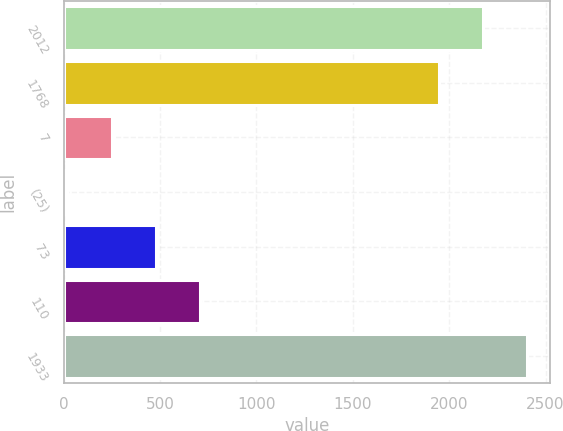<chart> <loc_0><loc_0><loc_500><loc_500><bar_chart><fcel>2012<fcel>1768<fcel>7<fcel>(25)<fcel>73<fcel>110<fcel>1933<nl><fcel>2174.9<fcel>1946<fcel>248.9<fcel>20<fcel>477.8<fcel>706.7<fcel>2403.8<nl></chart> 